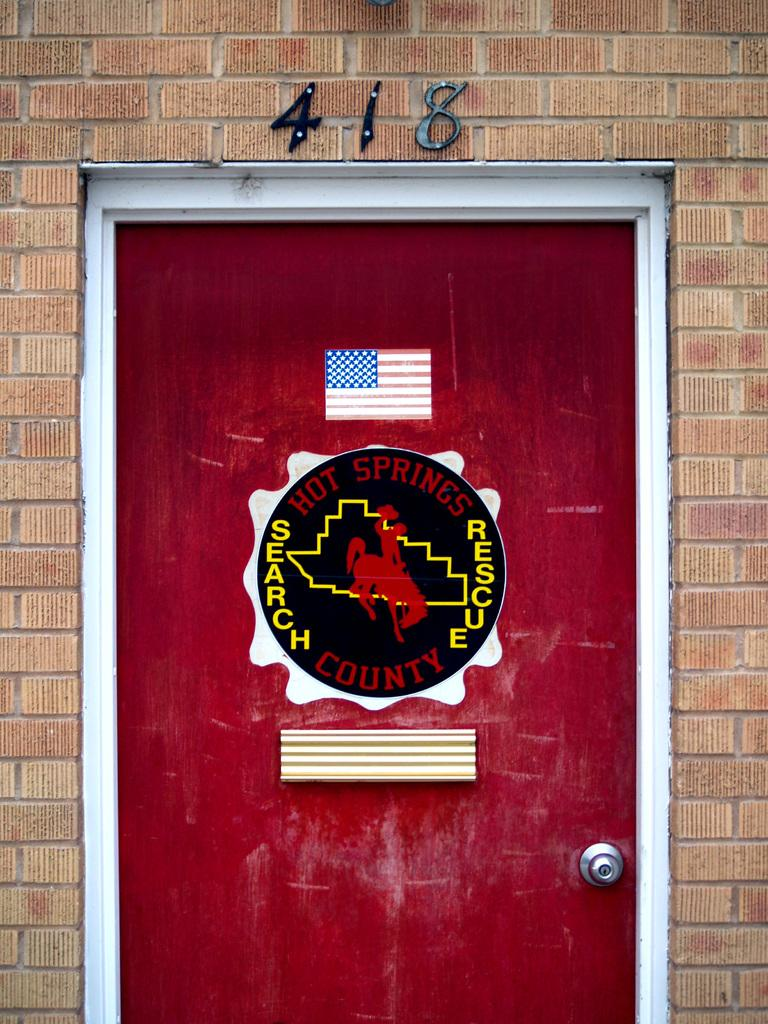What is present on the wall in the image? There is a wall in the image, and it has a door in it. What can be seen on the door? The door has a logo with text and a flag on it. Is there any additional information provided above the door? Yes, there is a number above the door on the wall. What type of brass material is used for the door handle in the image? There is no mention of a door handle in the image, so it cannot be determined if brass is used. 